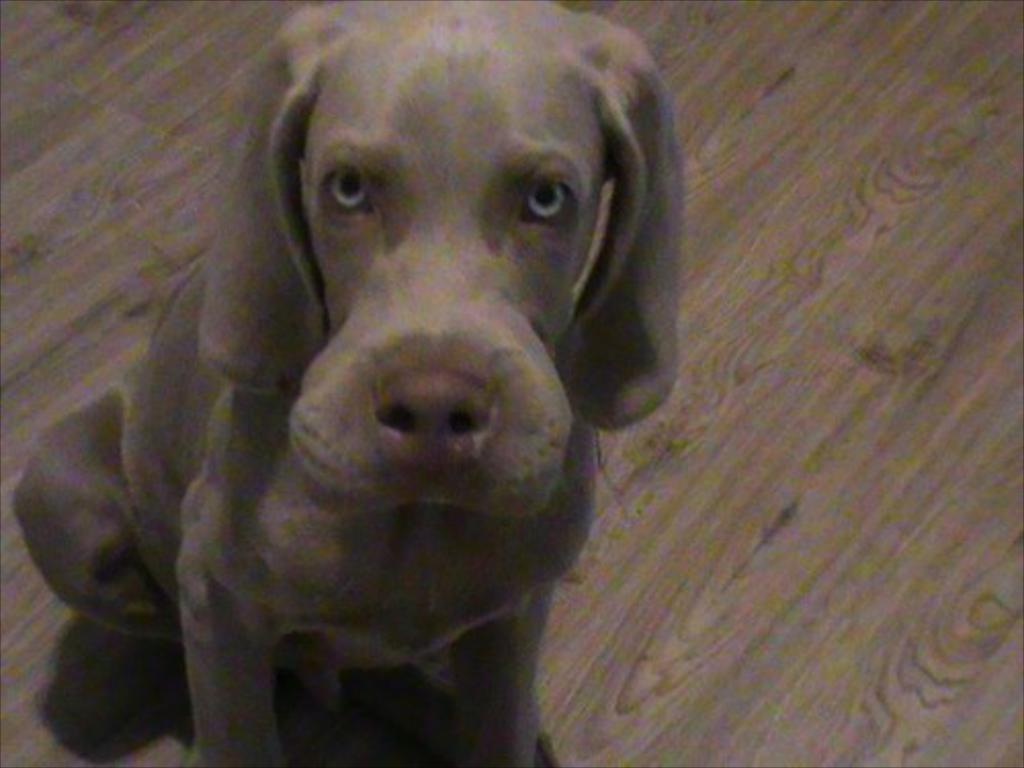What animal can be seen in the image? There is a dog in the image. What is the dog doing in the image? The dog is looking at the camera. What color is the background of the image? The background of the image is light brown in color. Where is the nest located in the image? There is no nest present in the image. How many dogs are in the group in the image? There is only one dog in the image, so it cannot be considered a group. 